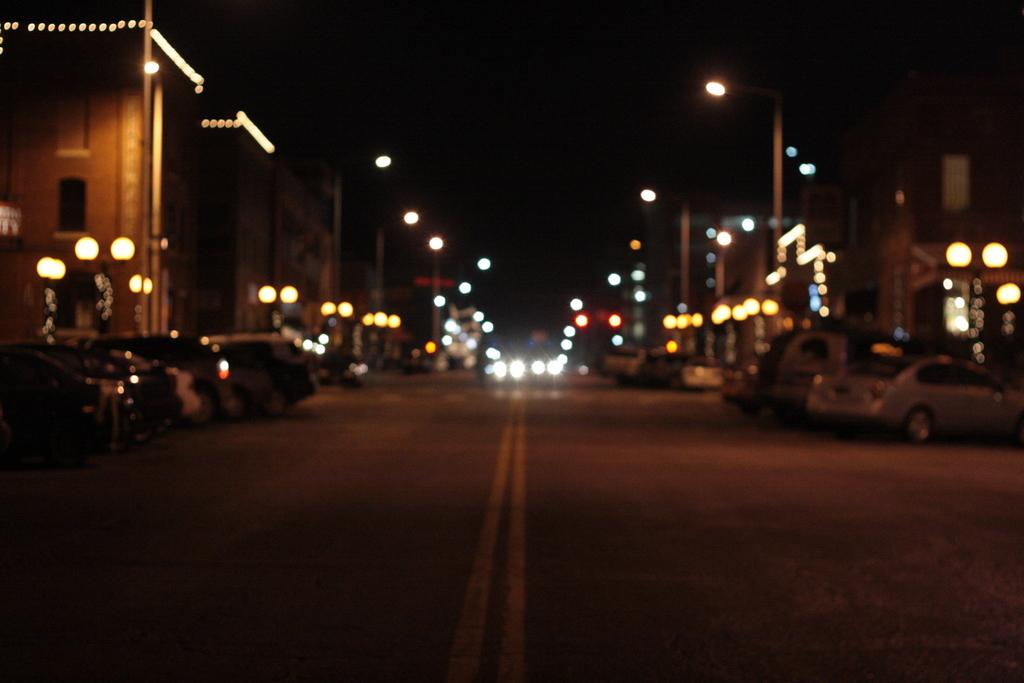What can be seen at the bottom of the image? There are vehicles on the road at the bottom of the image. What is visible in the background of the image? There are buildings in the background of the image. Can you describe any other elements in the image? Yes, there are lights visible in the image. Are there any beans visible in the image? No, there are no beans present in the image. What type of birds can be seen flying in the image? There are no birds visible in the image. 